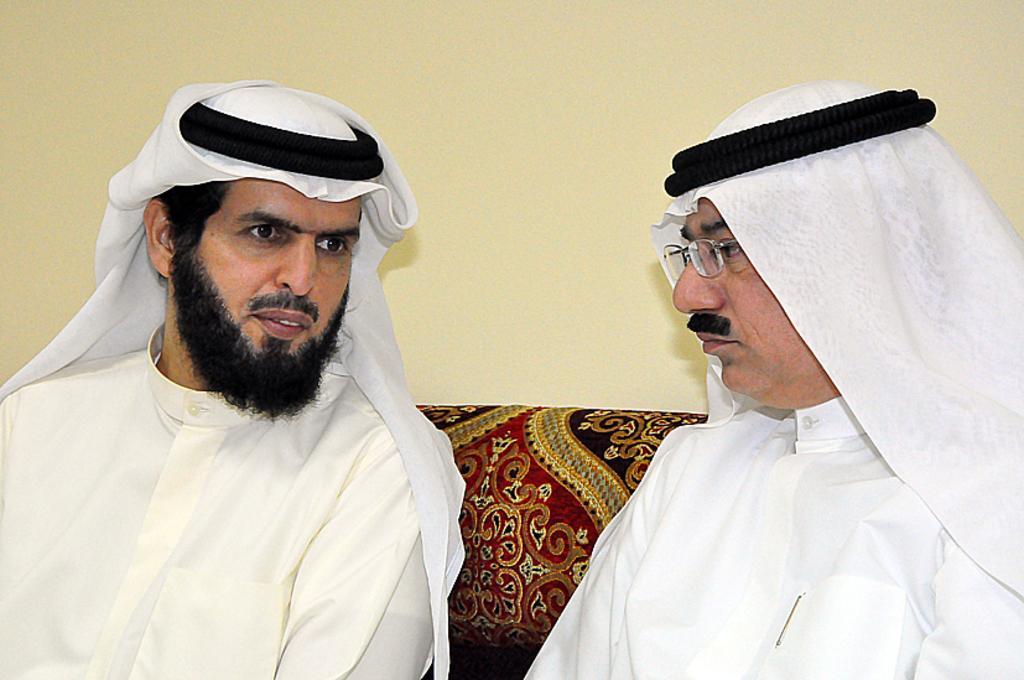Describe this image in one or two sentences. In the image we can see two men sitting, wearing clothes and the right side man is wearing spectacles, and we can see the wall. 